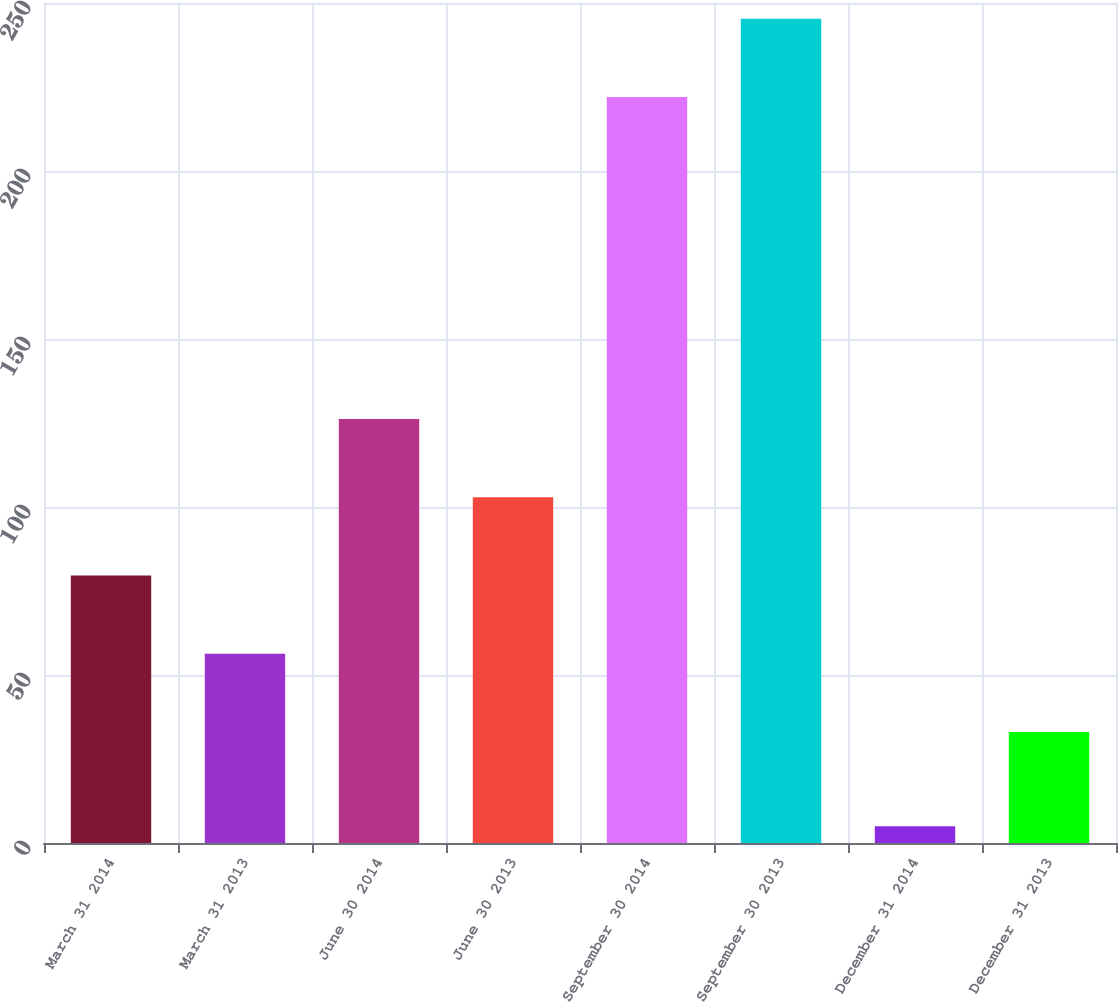Convert chart to OTSL. <chart><loc_0><loc_0><loc_500><loc_500><bar_chart><fcel>March 31 2014<fcel>March 31 2013<fcel>June 30 2014<fcel>June 30 2013<fcel>September 30 2014<fcel>September 30 2013<fcel>December 31 2014<fcel>December 31 2013<nl><fcel>79.6<fcel>56.3<fcel>126.2<fcel>102.9<fcel>222<fcel>245.3<fcel>5<fcel>33<nl></chart> 